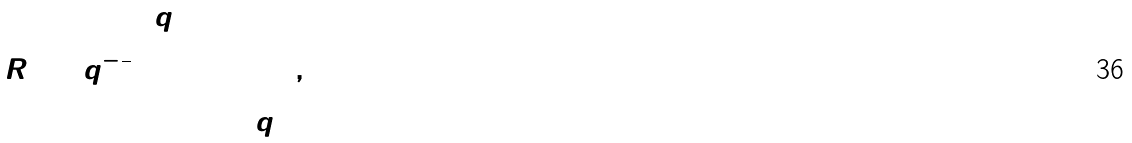Convert formula to latex. <formula><loc_0><loc_0><loc_500><loc_500>R _ { 0 } = q ^ { - \frac { 1 } { 2 } } ( \begin{array} { c c c c } q & 0 & 0 & 0 \\ 0 & 1 & 0 & 0 \\ 0 & 0 & 1 & 0 \\ 0 & 0 & 0 & q \end{array} ) ,</formula> 